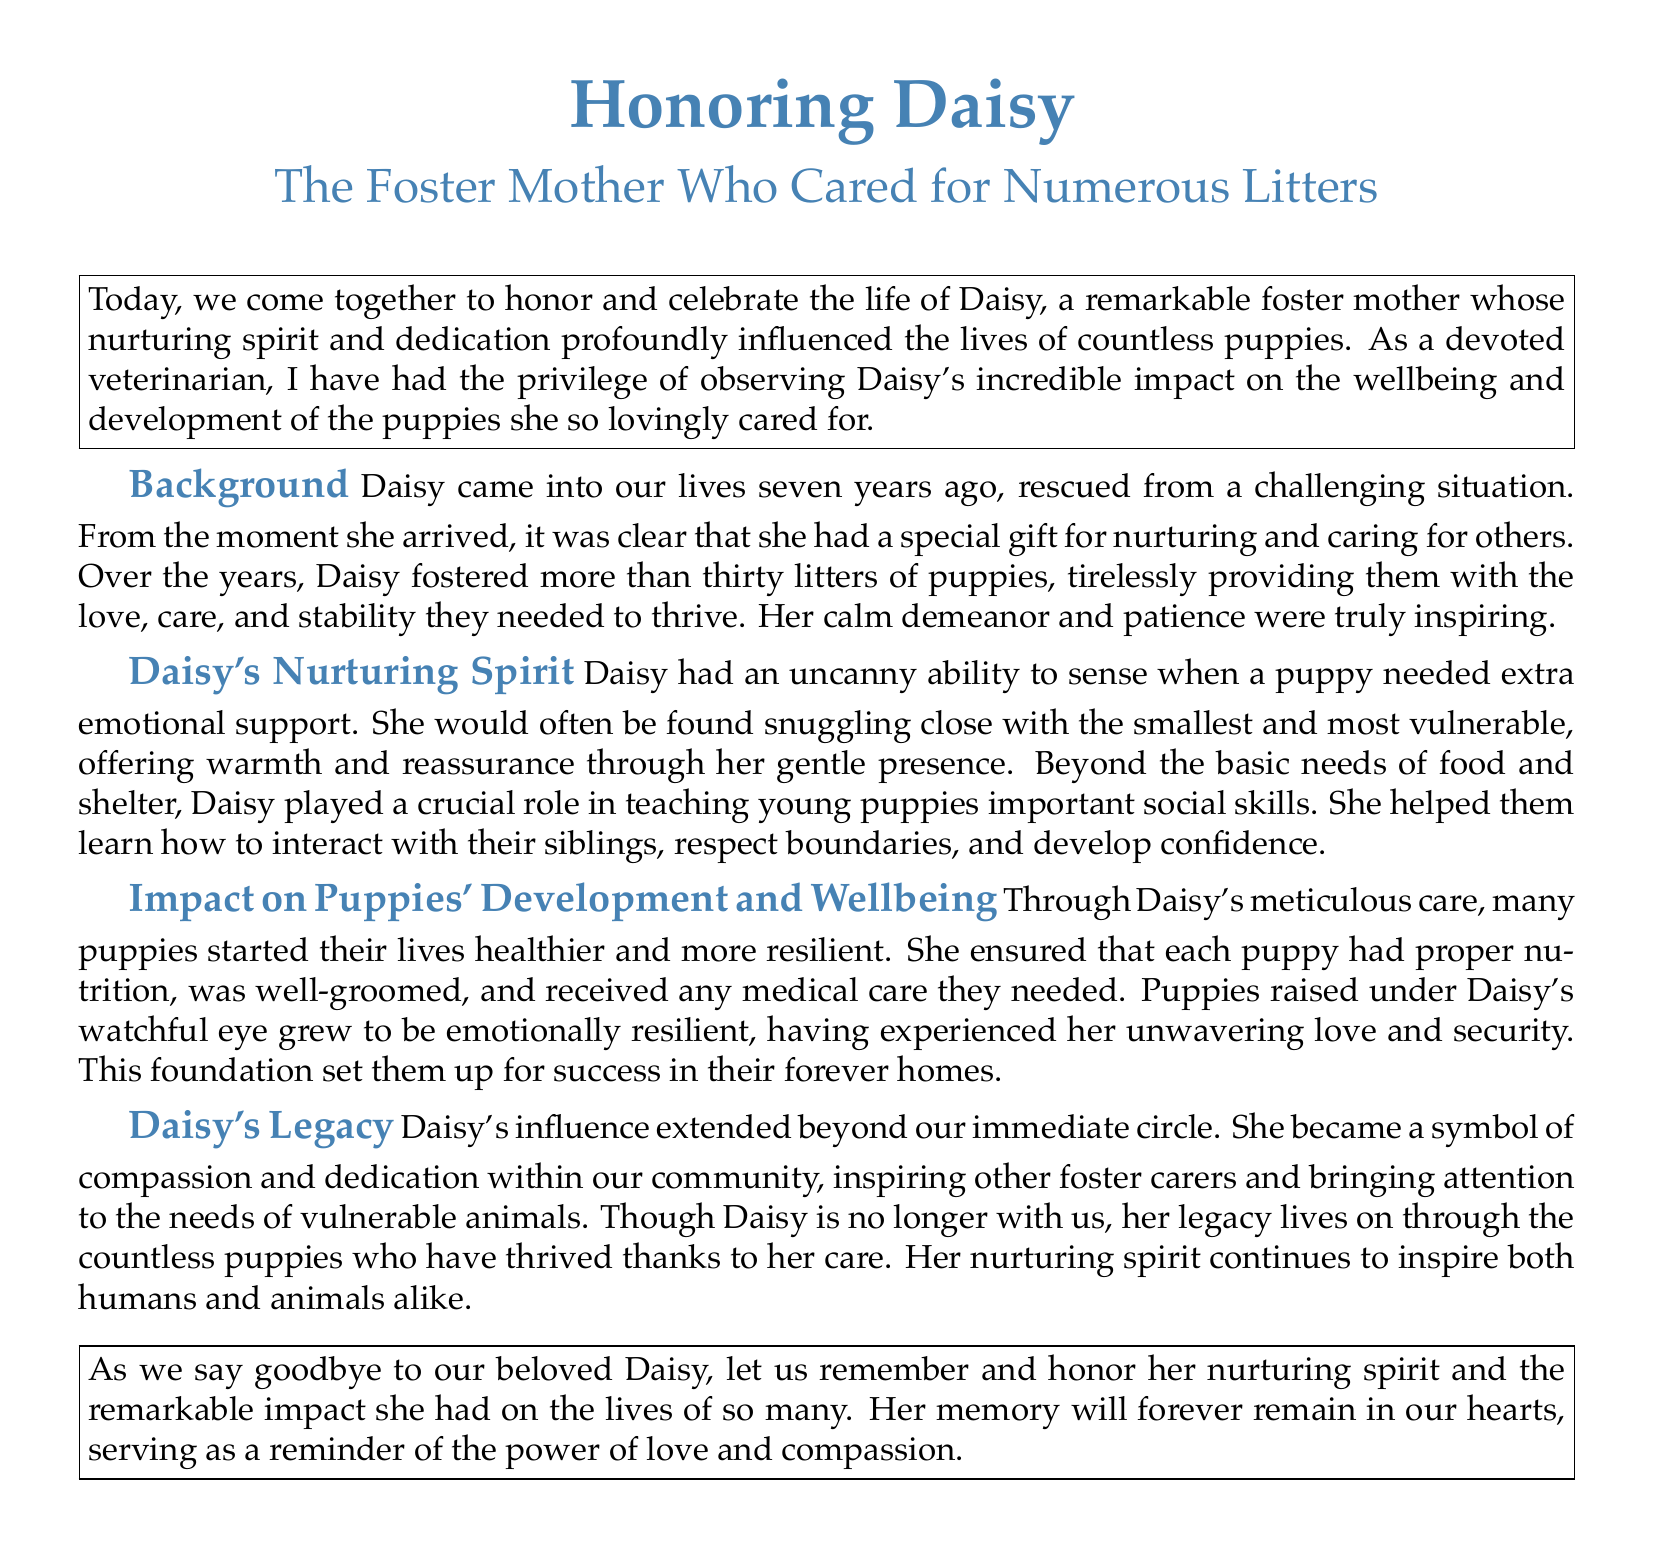What is the name of the foster mother being honored? The document clearly states that the foster mother's name is Daisy.
Answer: Daisy How many litters did Daisy foster? The document mentions that Daisy fostered more than thirty litters of puppies.
Answer: More than thirty What special skill did Daisy possess? The document describes Daisy's special gift as nurturing and caring for others.
Answer: Nurturing What was Daisy's approach to vulnerable puppies? The document indicates that Daisy often snuggled with the smallest and most vulnerable puppies to offer warmth and reassurance.
Answer: Snuggling What impact did Daisy have on the puppies' emotional resilience? The document explains that puppies raised under Daisy's care grew to be emotionally resilient due to her unwavering love and security.
Answer: Emotionally resilient What symbol did Daisy become in the community? According to the document, Daisy became a symbol of compassion and dedication within the community.
Answer: Compassion What does the document state about Daisy's legacy? The document highlights that Daisy's legacy lives on through the countless puppies who thrived thanks to her care.
Answer: Countless puppies How long ago did Daisy come into our lives? The document specifies that Daisy came into our lives seven years ago.
Answer: Seven years 